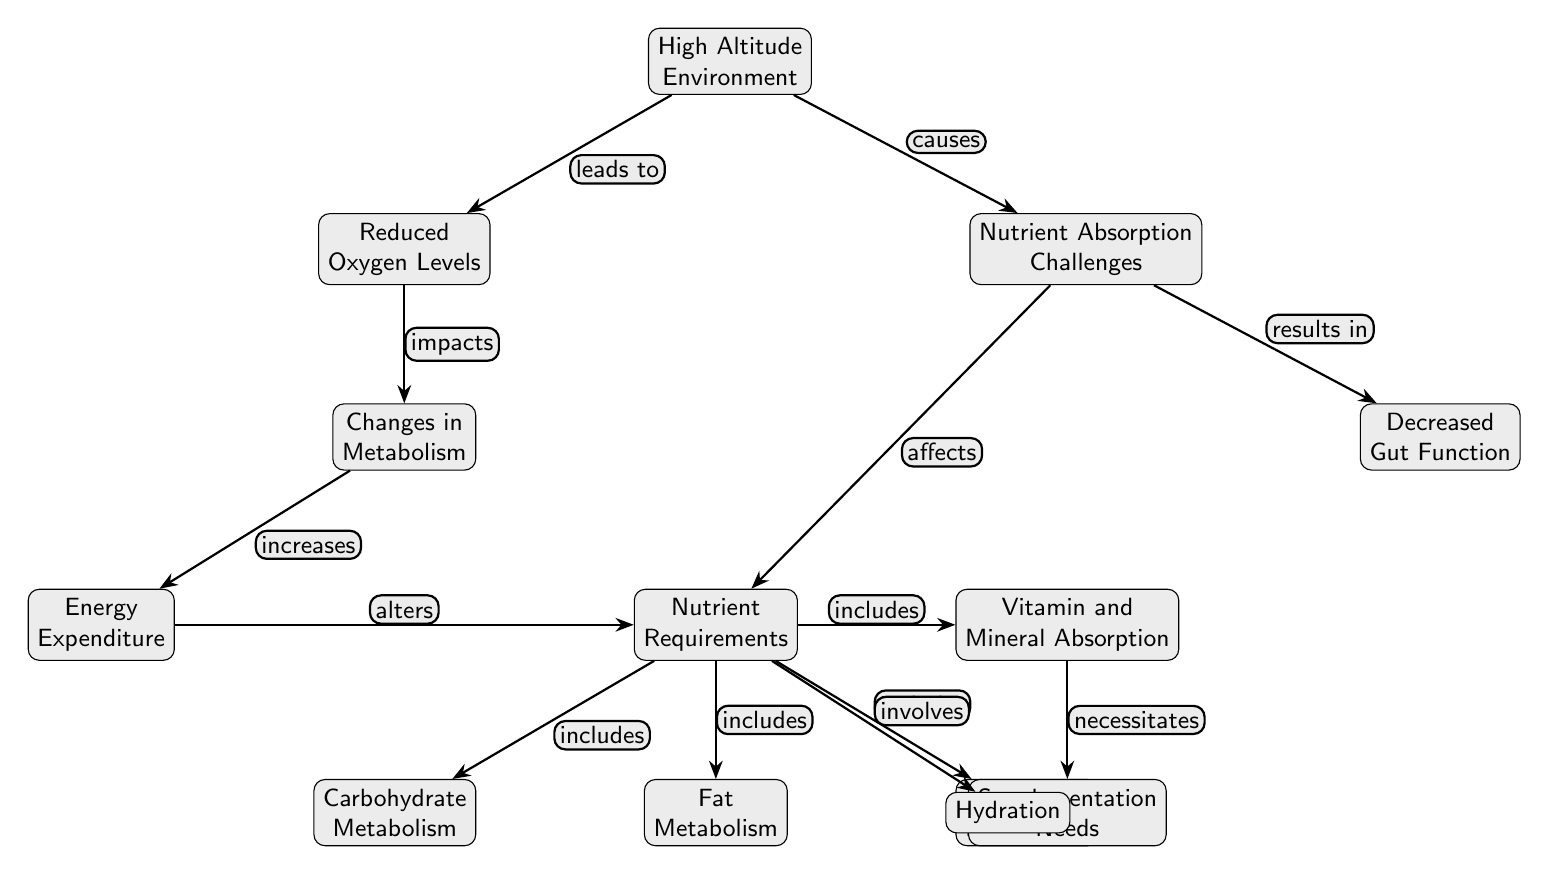What is the first node in the diagram? The first node is labeled "High Altitude Environment," which is at the top of the diagram.
Answer: High Altitude Environment How many main nodes are there in total? By counting each of the distinct labeled nodes within the diagram, we find there are a total of 13 nodes.
Answer: 13 Which node is directly affected by "Reduced Oxygen Levels"? The node that is directly affected by "Reduced Oxygen Levels" is "Changes in Metabolism," indicating a relationship of cause and effect.
Answer: Changes in Metabolism What relationship exists between "Nutrient Absorption Challenges" and "Decreased Gut Function"? The relationship is one of resulting effect; "Nutrient Absorption Challenges" results in "Decreased Gut Function" as indicated by the edge labeled "results in."
Answer: results in What increases as a result of changes in metabolism according to the diagram? The changes in metabolism lead to an increase in "Energy Expenditure," which reflects the body's response to high altitude conditions.
Answer: Energy Expenditure Which node necessitates "Supplementation Needs"? The node "Vitamin and Mineral Absorption" necessitates "Supplementation Needs," as shown by the edge connecting them labeled "necessitates."
Answer: Supplementation Needs What are the three types of metabolism included under "Nutrient Requirements"? The three types of metabolism included are "Carbohydrate Metabolism," "Fat Metabolism," and "Protein Metabolism," all connected to "Nutrient Requirements."
Answer: Carbohydrate Metabolism, Fat Metabolism, Protein Metabolism How does "Nutrient Absorption Challenges" affect "Nutrient Requirements"? "Nutrient Absorption Challenges" affects "Nutrient Requirements" by indicating that challenges in absorption necessitate specific nutrient intake, reflecting a direct impact as depicted in the diagram.
Answer: affects What is the function of the "Hydration" node in relation to "Nutrient Requirements"? The "Hydration" node is involved in "Nutrient Requirements," suggesting a connection where hydration is essential for optimal nutrient utilization in high altitude environments.
Answer: involves 